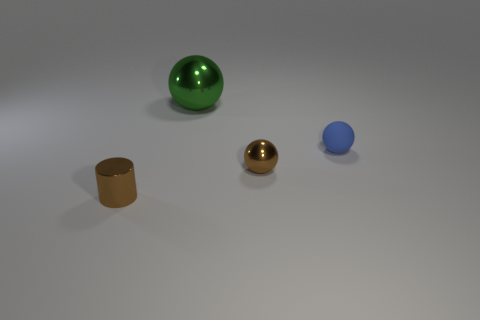Subtract all tiny balls. How many balls are left? 1 Add 2 small yellow metal spheres. How many objects exist? 6 Subtract all spheres. How many objects are left? 1 Subtract 1 green balls. How many objects are left? 3 Subtract 1 cylinders. How many cylinders are left? 0 Subtract all gray spheres. Subtract all cyan cubes. How many spheres are left? 3 Subtract all small brown shiny things. Subtract all green shiny things. How many objects are left? 1 Add 1 green shiny things. How many green shiny things are left? 2 Add 2 large objects. How many large objects exist? 3 